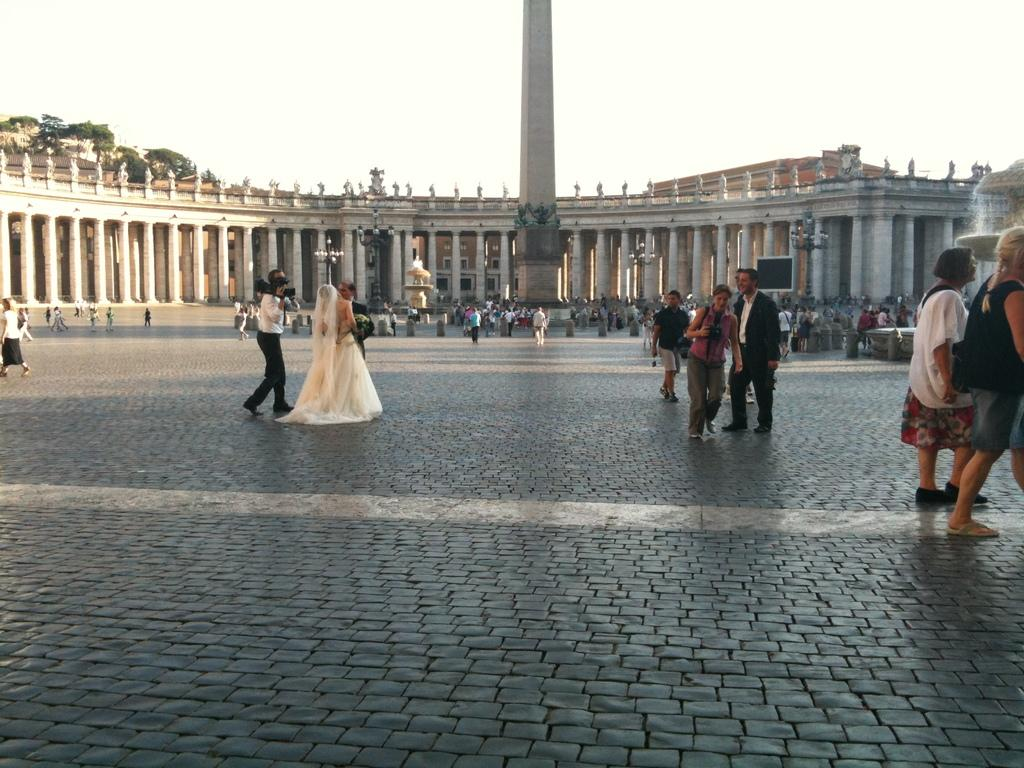What is happening in the center of the image? There are people on the pavement in the center of the image. What can be seen in the background of the image? There is a building with pillars, a tower, trees, and the sky visible in the background of the image. What type of knowledge is being shared by the people on the pavement in the image? There is no indication of any knowledge being shared in the image; it simply shows people on the pavement. Can you tell me how many skates are visible in the image? There are no skates present in the image. 